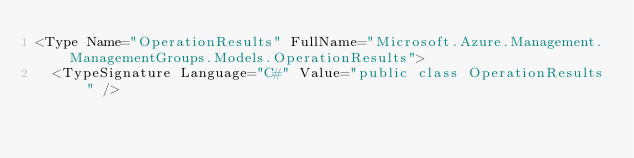<code> <loc_0><loc_0><loc_500><loc_500><_XML_><Type Name="OperationResults" FullName="Microsoft.Azure.Management.ManagementGroups.Models.OperationResults">
  <TypeSignature Language="C#" Value="public class OperationResults" /></code> 